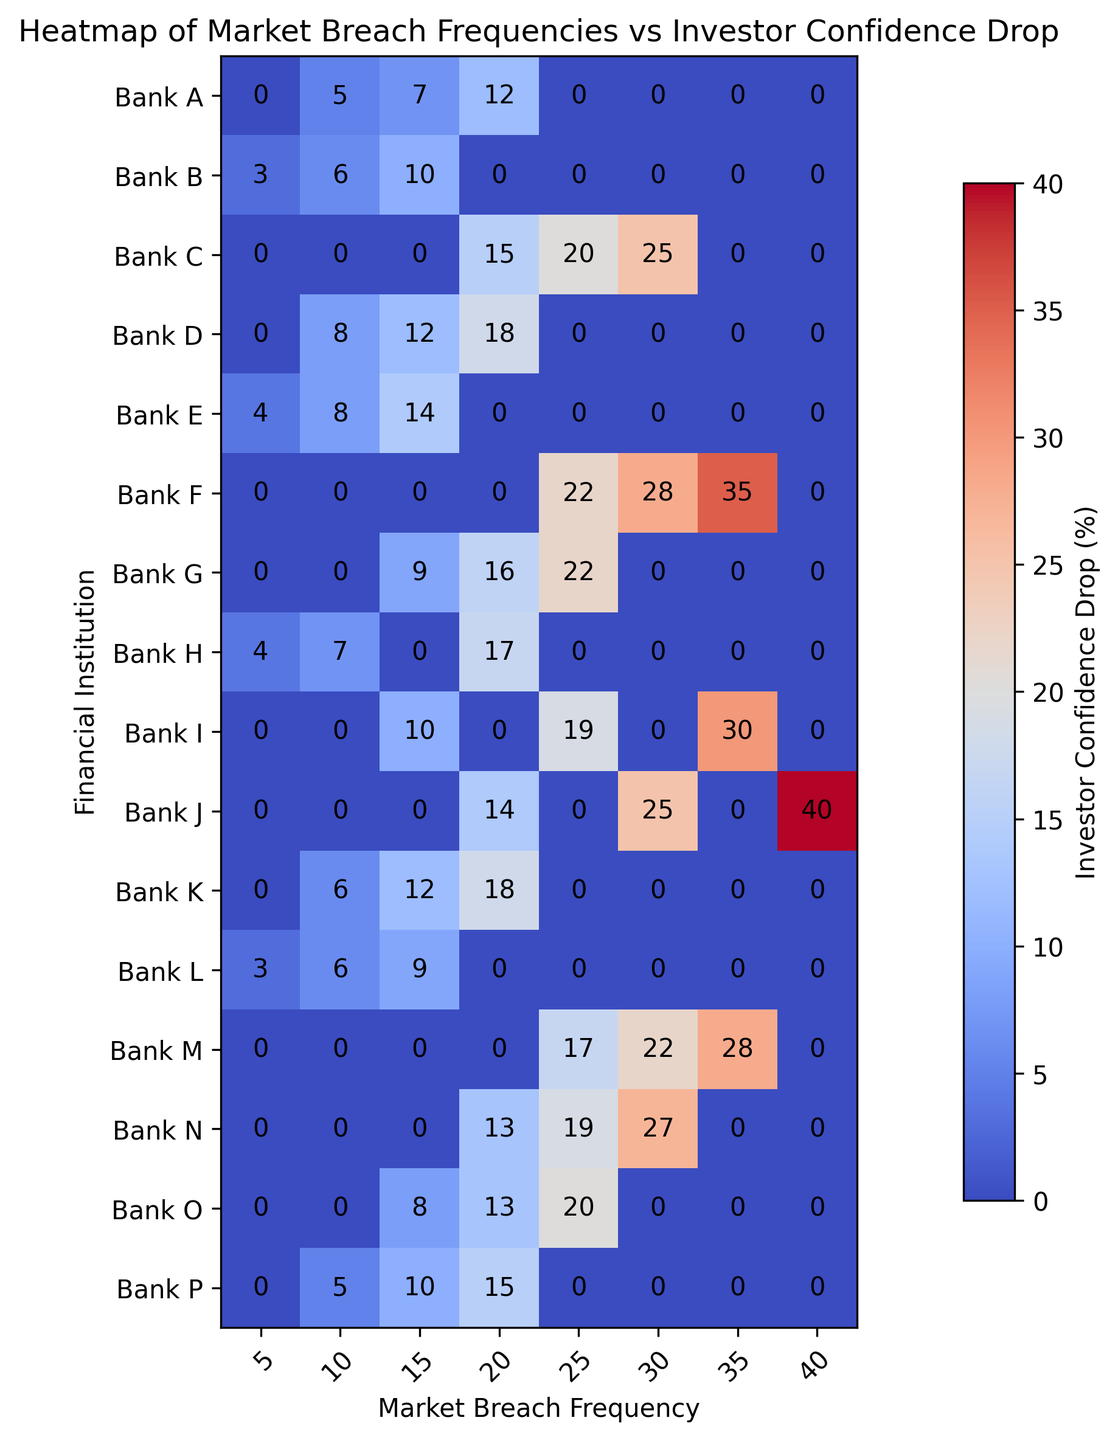What's the market breach frequency with the highest investor confidence drop at Bank J? Identify the row corresponding to Bank J, then locate the column with the highest value within that row. The highest value in Bank J's row is 40 under the 40 market breach frequency.
Answer: 40 Which bank shows the strongest impact (highest confidence drop) from a market breach frequency of 30? Look across the column for the market breach frequency of 30 and find the highest value. Bank J has the highest drop of 25% for this frequency, displayed as a red color in the heatmap.
Answer: Bank J How does the confidence drop at Bank B for a market breach frequency of 15 compare to that at Bank G for the same frequency? From the heatmap, locate the 15 market breach frequency for both Bank B and Bank G. Bank B has a drop of 10% whereas Bank G has a drop of 9%. Therefore, Bank B's confidence drop is slightly higher.
Answer: Bank B shows a higher confidence drop What is the average investor confidence drop at Bank C for market breach frequencies of 20, 25, and 30? Sum the values of confidence drop at Bank C for frequencies 20, 25, and 30 (15 + 20 + 25 = 60) and divide this sum by the number of instances (3). The average is thus 60 / 3 = 20.
Answer: 20% Which financial institution demonstrates the lowest investor confidence drop at a market breach frequency of 10? Locate the column for a market breach frequency of 10 and identify the bank with the lowest entry. This is Bank L with a confidence drop of 6%.
Answer: Bank L What is the combined investor confidence drop at Bank E for market breach frequencies of 5, 10, and 15? Add the values for market breach frequencies of 5, 10, and 15 at Bank E (4 + 8 + 14 = 26). Therefore, the combined confidence drop is 26.
Answer: 26% Compare the impact on investor confidence drops between financial institutions with the highest drop at a market breach frequency of 25. Look at the column for a market breach frequency of 25 and compare values. Bank F and Bank J both have the highest drop with 35%.
Answer: Bank F and Bank J have equal highest drops Which bank has the widest range of investor confidence drop values? To find the widest range, subtract the minimum value from the maximum value for each bank. Bank J has values ranging from 14 to 40, resulting in a range of 26, which is the largest.
Answer: Bank J 